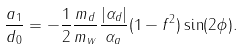Convert formula to latex. <formula><loc_0><loc_0><loc_500><loc_500>\frac { a _ { 1 } } { d _ { 0 } } = - \frac { 1 } { 2 } \frac { { m _ { d } } } { { m _ { w } } } \frac { | { \alpha _ { d } } | } { { \alpha _ { a } } } ( 1 - f ^ { 2 } ) \sin ( 2 \phi ) .</formula> 